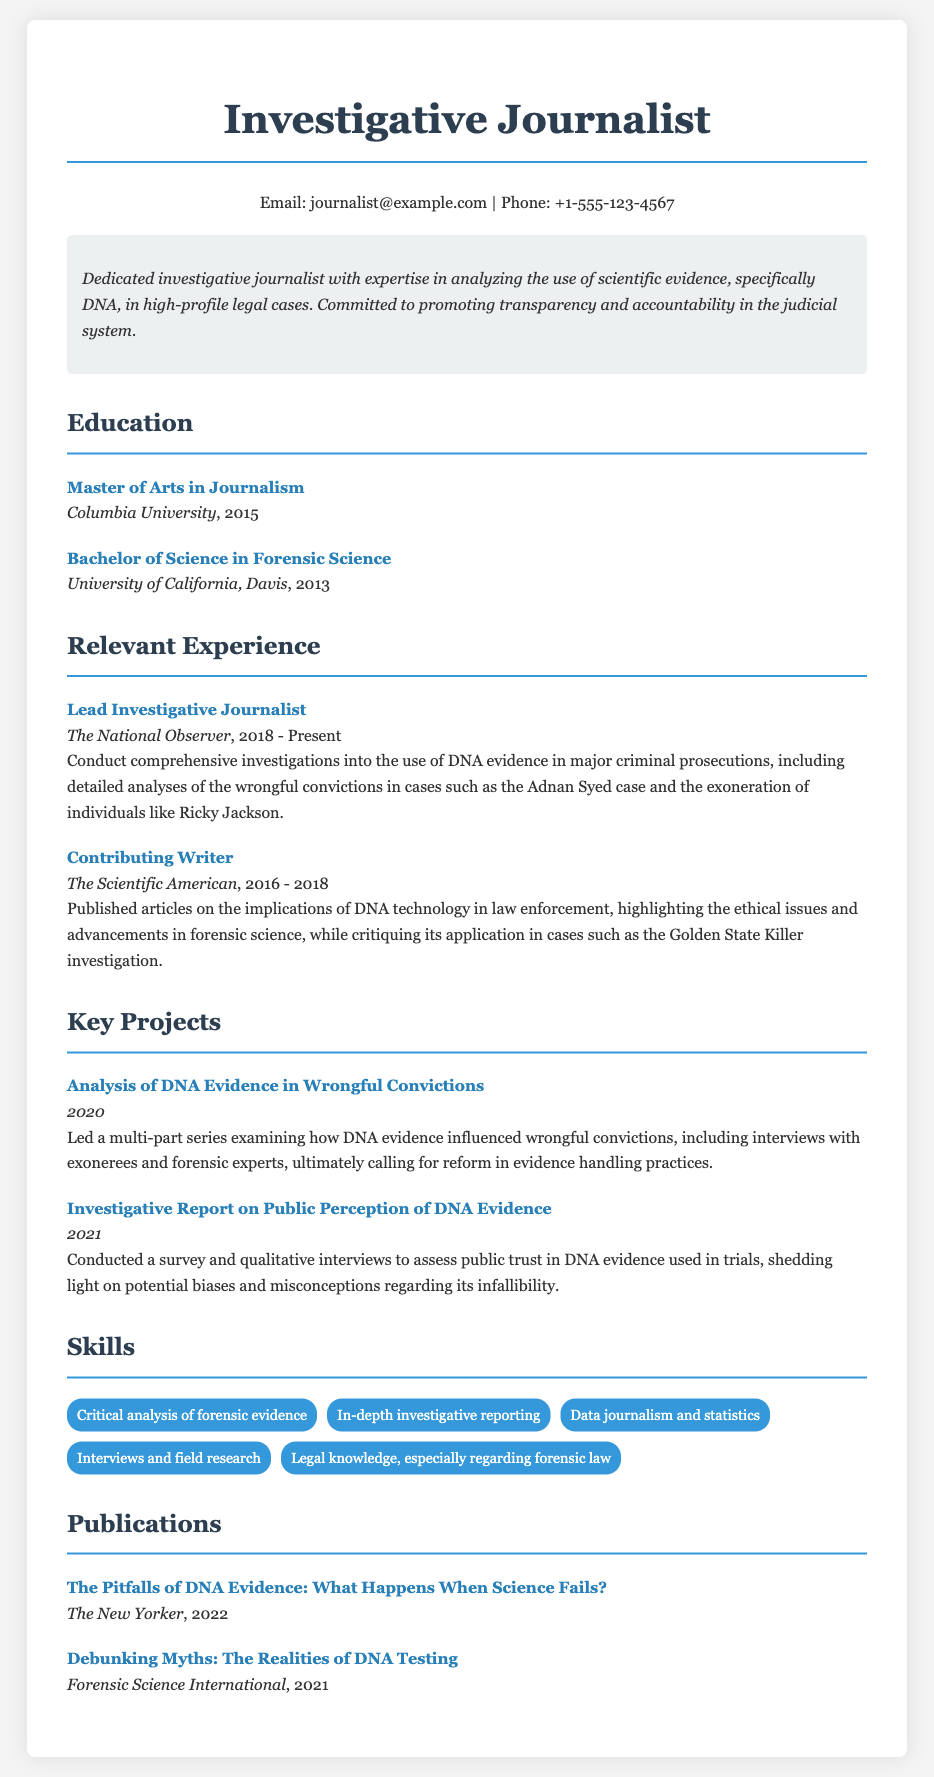what is the name of the investigative journalist? The name listed at the top of the document is the title of the profession which is "Investigative Journalist."
Answer: Investigative Journalist which university did the author attend for their Master of Arts? The document specifies the institution where the Master of Arts was earned, which is Columbia University.
Answer: Columbia University what is the publication year of the article "Debunking Myths: The Realities of DNA Testing"? The publication date is explicitly stated in the document next to the title of the article.
Answer: 2021 who is the current employer of the investigative journalist? The document indicates the current position and employer of the journalist, which is The National Observer.
Answer: The National Observer what was the focus of the 2020 project led by the journalist? The project described involves examining how DNA evidence influenced wrongful convictions, as stated explicitly in the document.
Answer: DNA Evidence in Wrongful Convictions how many years did the journalist work at The Scientific American? The document specifies the time period of employment at The Scientific American, from 2016 to 2018, which is a span of 2 years.
Answer: 2 years what is the main commitment highlighted in the summary section? The summary outlines the journalist's dedication towards promoting a specific principle in the judicial system, which is transparency and accountability.
Answer: Transparency and accountability name one skill mentioned in the skills section. The document lists various skills, any one of which can be an answer, such as "Critical analysis of forensic evidence."
Answer: Critical analysis of forensic evidence what is the title of the publication in 2022? The title of the publication is presented directly in the document along with the year, which is "The Pitfalls of DNA Evidence: What Happens When Science Fails?"
Answer: The Pitfalls of DNA Evidence: What Happens When Science Fails? 